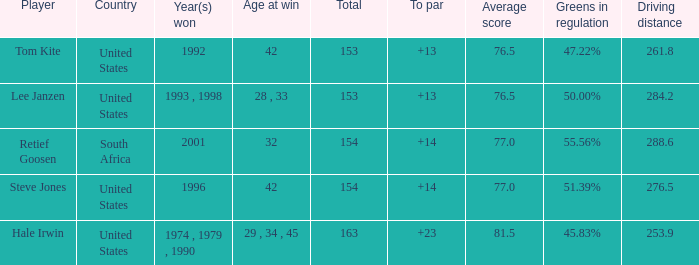What is the total that South Africa had a par greater than 14 None. 